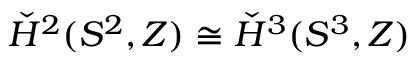<formula> <loc_0><loc_0><loc_500><loc_500>\check { H } ^ { 2 } ( S ^ { 2 } , Z ) \cong \check { H } ^ { 3 } ( S ^ { 3 } , Z )</formula> 